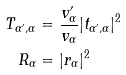Convert formula to latex. <formula><loc_0><loc_0><loc_500><loc_500>T _ { \alpha ^ { \prime } , \alpha } & = \frac { v _ { \alpha } ^ { \prime } } { v _ { \alpha } } | t _ { \alpha ^ { \prime } , \alpha } | ^ { 2 } \\ R _ { \alpha } & = | r _ { \alpha } | ^ { 2 }</formula> 